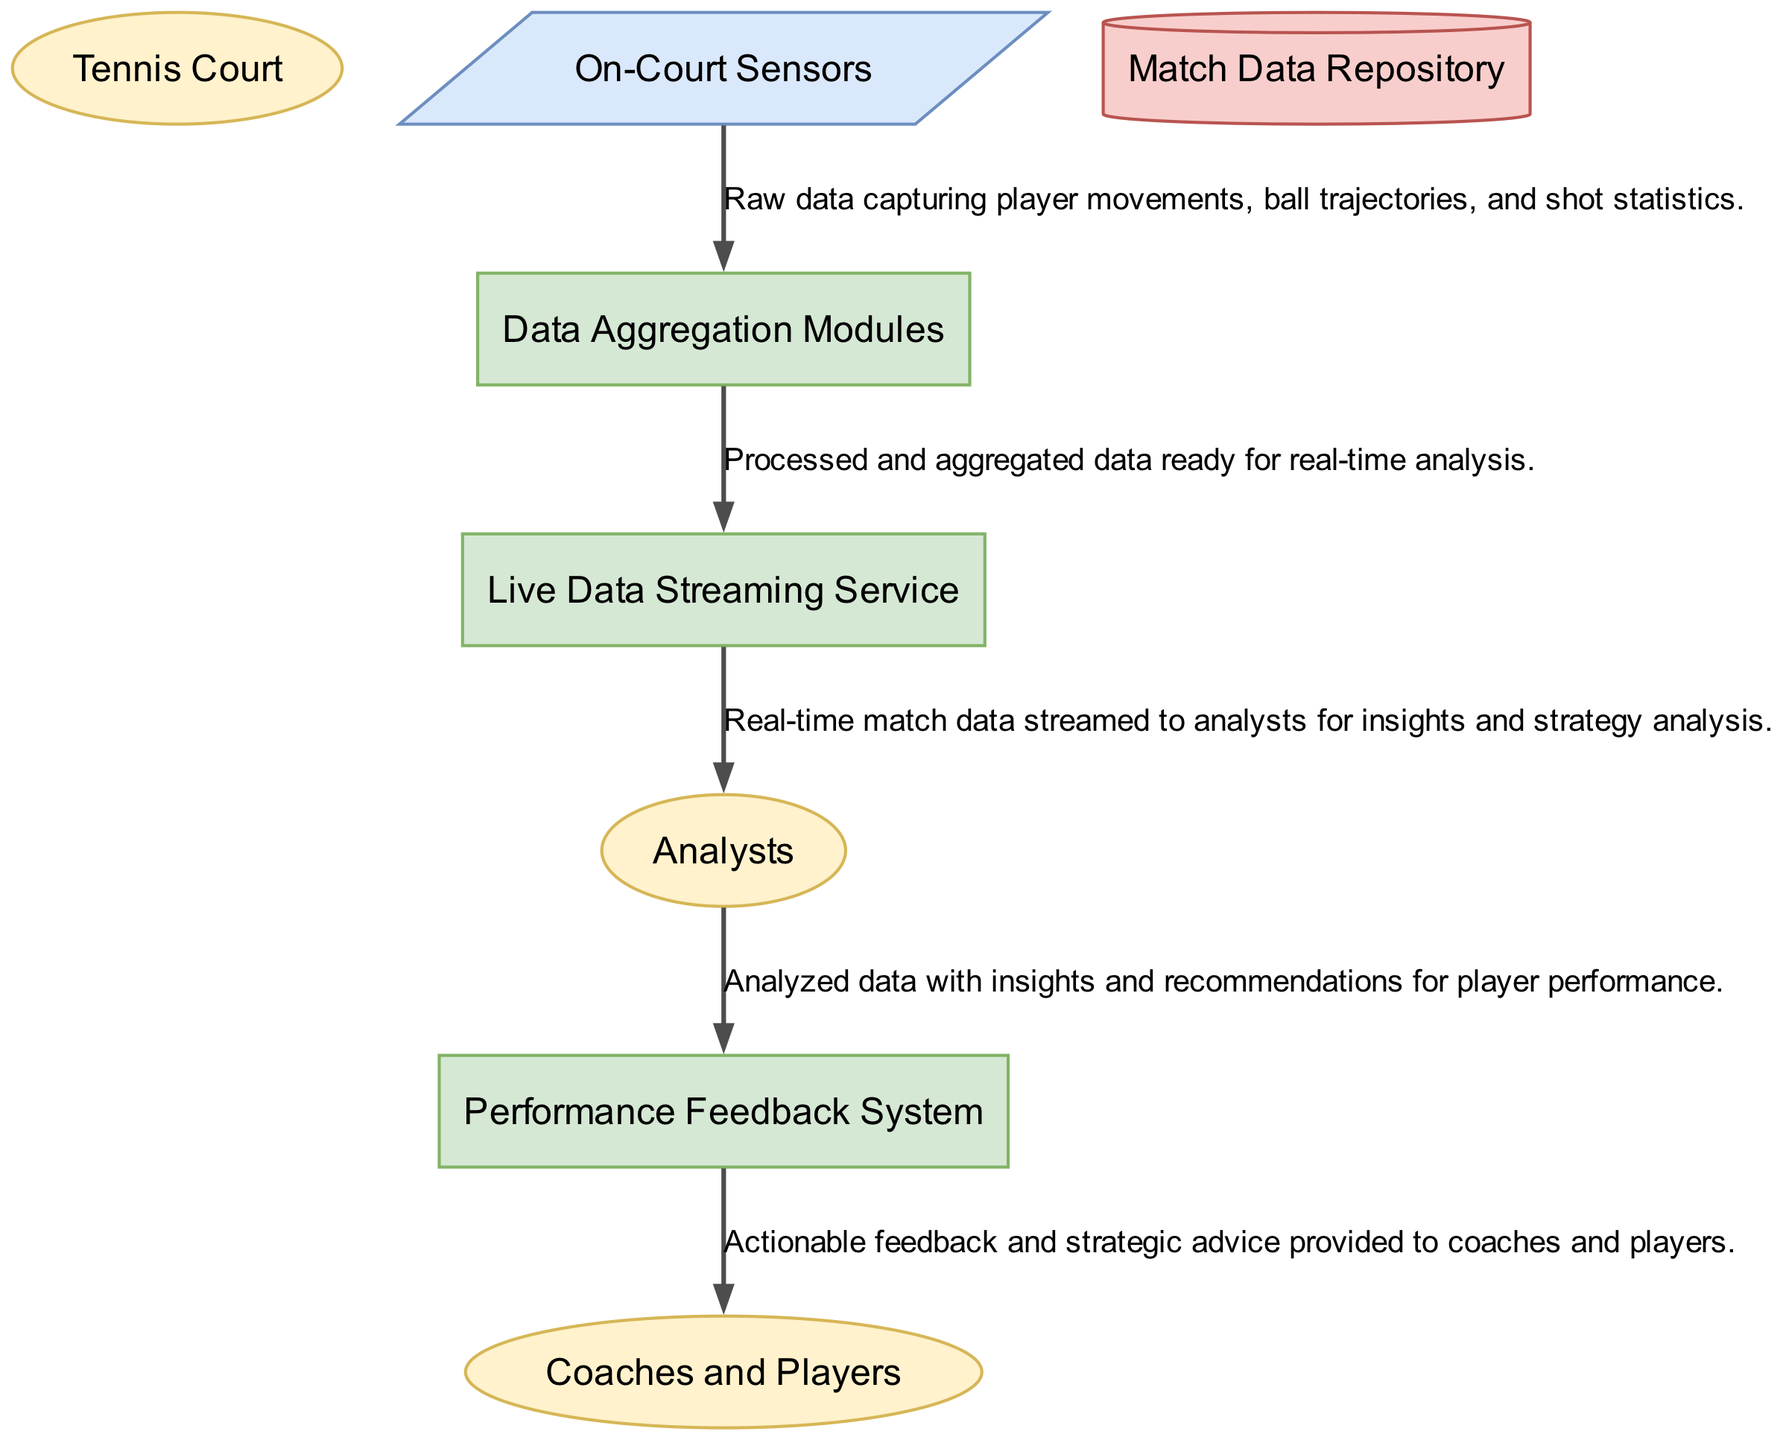What type of entity is the "On-Court Sensors"? Looking at the diagram, the "On-Court Sensors" is defined under the category "Source," indicating that it is a type of node that generates data to be processed.
Answer: Source How many external entities are shown in the diagram? By counting the nodes labeled as "External Entity," we notice that there are three: "Tennis Court," "Analysts," and "Coaches and Players."
Answer: 3 What data flows from "Data Aggregation Modules" to "Live Data Streaming Service"? The description of the data flow indicates that it consists of “Processed and aggregated data ready for real-time analysis." This flow defines the relationship between these two processes in the data flow diagram.
Answer: Processed and aggregated data ready for real-time analysis Which node receives data from the "Live Data Streaming Service"? According to the connections in the diagram, the flow from the "Live Data Streaming Service" leads directly to the "Analysts," showing that they receive the data for analysis.
Answer: Analysts What is the primary function of the "Performance Feedback System"? The description in the diagram states that its function is to provide “actionable insights and feedback to players and coaches based on the analyzed data," indicating its role in performance improvement.
Answer: Actionable insights and feedback How is data from "Analysts" used in the system? The diagram shows that "Analysts" send analyzed data to the "Performance Feedback System," suggesting that their role is to analyze performance data and generate recommendations based on it.
Answer: Analyzed data with insights and recommendations What type of diagram is being represented here? The content and structure present in the diagram are indicative of a Data Flow Diagram, which emphasizes the flow of information between processes, sources, and external entities.
Answer: Data Flow Diagram What entity provides strategic advice based on match data? The "Performance Feedback System" is designated to offer strategic advice to "Coaches and Players," as it aggregates analyzed information to generate insights.
Answer: Performance Feedback System 